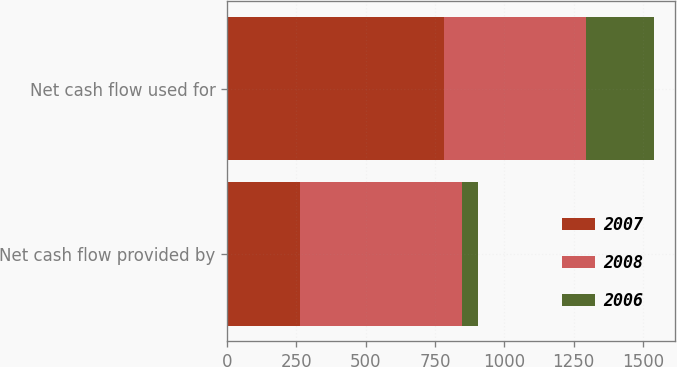Convert chart to OTSL. <chart><loc_0><loc_0><loc_500><loc_500><stacked_bar_chart><ecel><fcel>Net cash flow provided by<fcel>Net cash flow used for<nl><fcel>2007<fcel>262.4<fcel>781.4<nl><fcel>2008<fcel>584.1<fcel>511.6<nl><fcel>2006<fcel>59.4<fcel>246.2<nl></chart> 